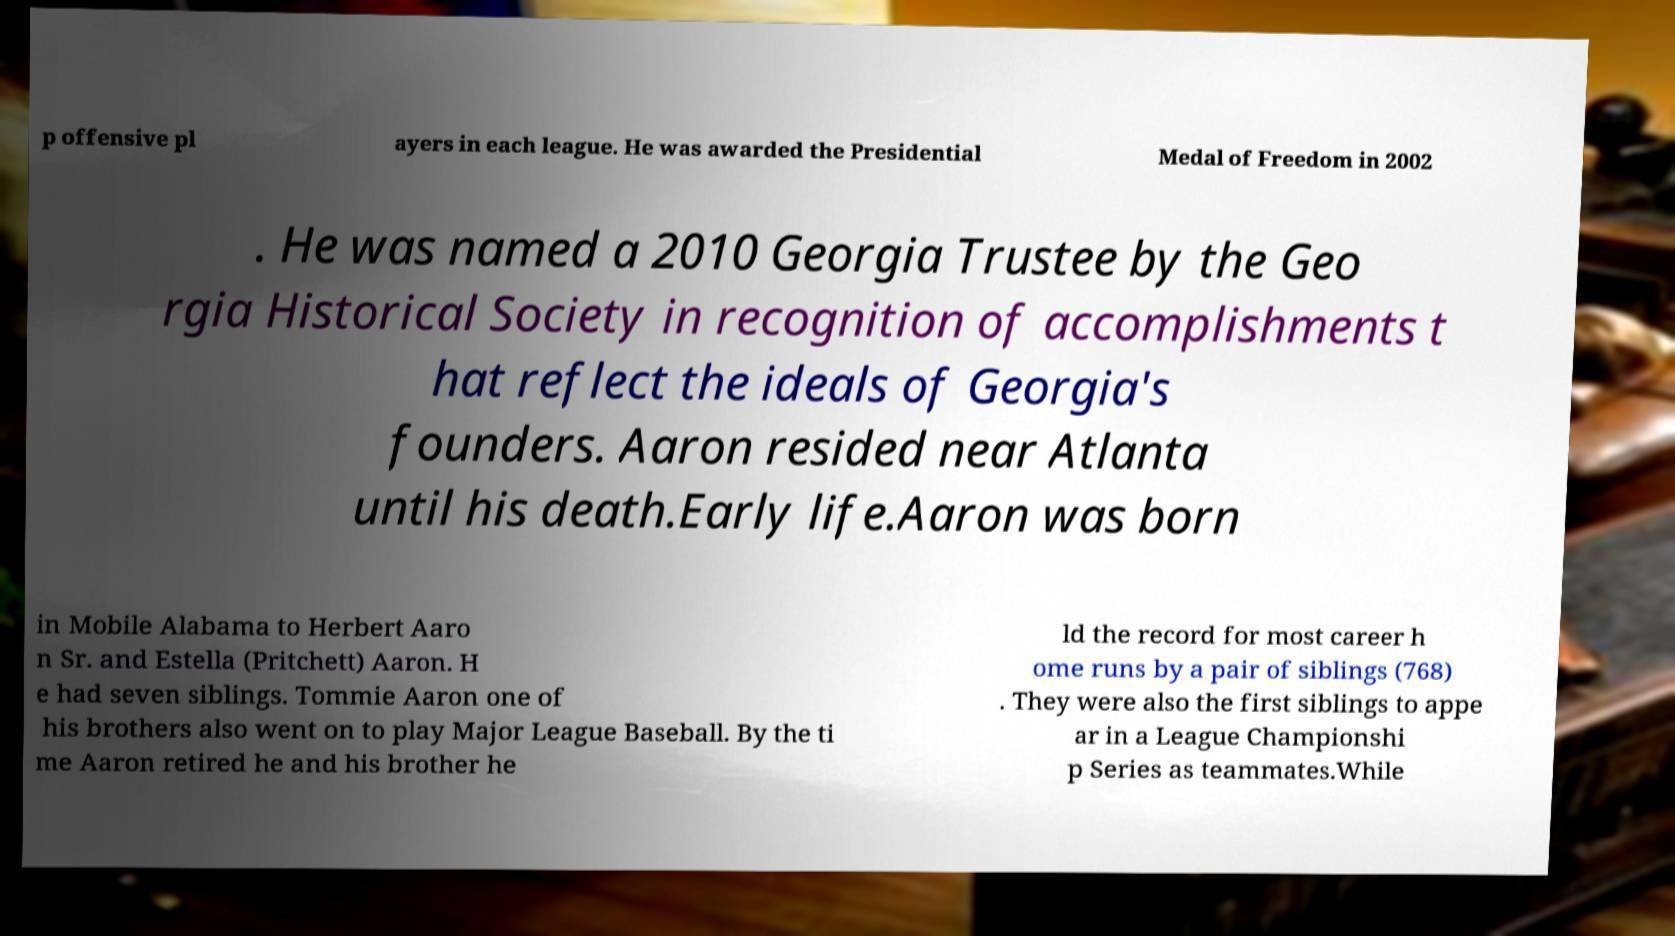I need the written content from this picture converted into text. Can you do that? p offensive pl ayers in each league. He was awarded the Presidential Medal of Freedom in 2002 . He was named a 2010 Georgia Trustee by the Geo rgia Historical Society in recognition of accomplishments t hat reflect the ideals of Georgia's founders. Aaron resided near Atlanta until his death.Early life.Aaron was born in Mobile Alabama to Herbert Aaro n Sr. and Estella (Pritchett) Aaron. H e had seven siblings. Tommie Aaron one of his brothers also went on to play Major League Baseball. By the ti me Aaron retired he and his brother he ld the record for most career h ome runs by a pair of siblings (768) . They were also the first siblings to appe ar in a League Championshi p Series as teammates.While 